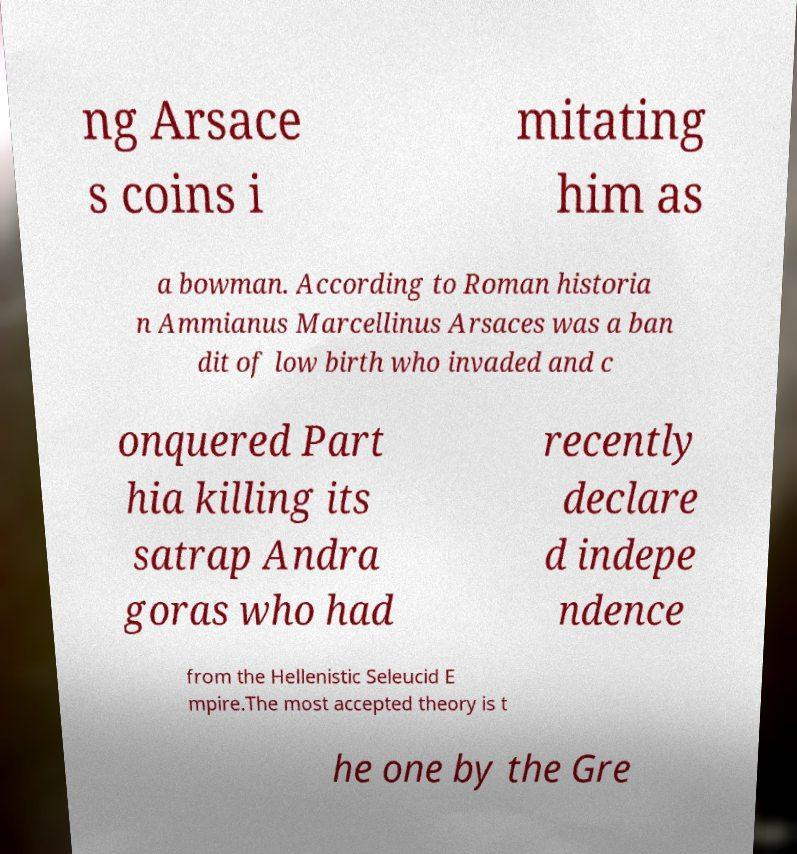Can you read and provide the text displayed in the image?This photo seems to have some interesting text. Can you extract and type it out for me? ng Arsace s coins i mitating him as a bowman. According to Roman historia n Ammianus Marcellinus Arsaces was a ban dit of low birth who invaded and c onquered Part hia killing its satrap Andra goras who had recently declare d indepe ndence from the Hellenistic Seleucid E mpire.The most accepted theory is t he one by the Gre 